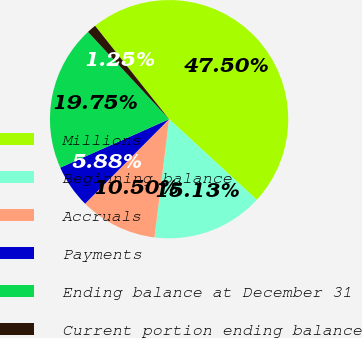<chart> <loc_0><loc_0><loc_500><loc_500><pie_chart><fcel>Millions<fcel>Beginning balance<fcel>Accruals<fcel>Payments<fcel>Ending balance at December 31<fcel>Current portion ending balance<nl><fcel>47.5%<fcel>15.13%<fcel>10.5%<fcel>5.88%<fcel>19.75%<fcel>1.25%<nl></chart> 